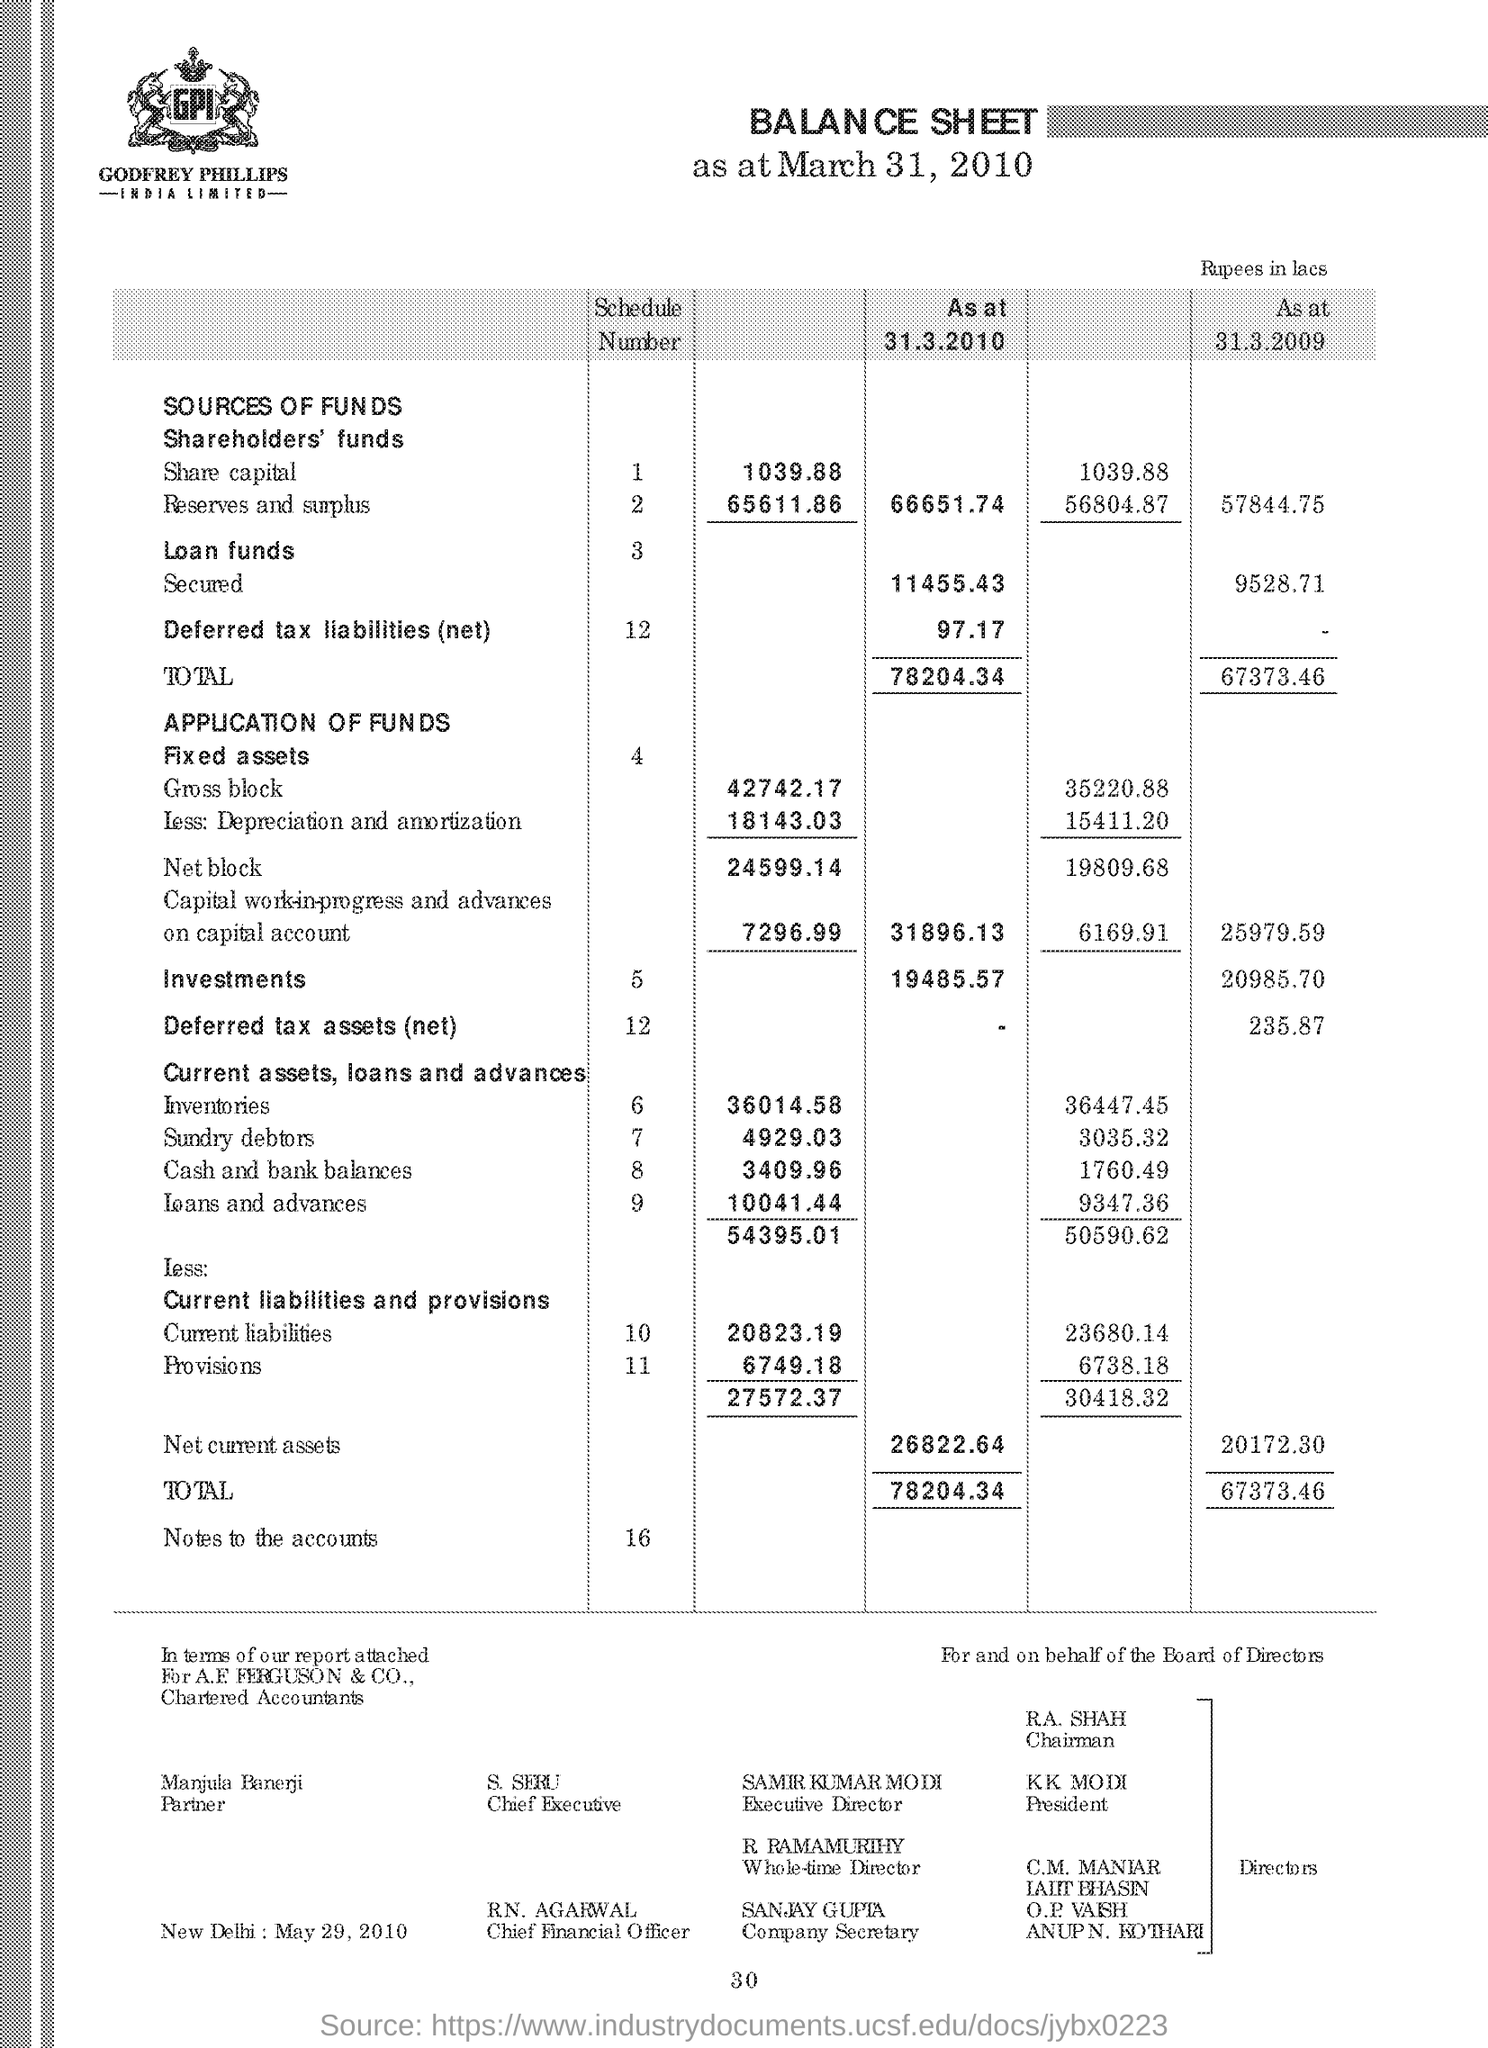What is the Net current assets as at 31.3.2010?
Provide a short and direct response. 26822.64. What is the Net current assets as at 31.3.2009?
Offer a terse response. 20172.30. What is the Total as at 31.3.2010?
Offer a terse response. 78204.34. What is the Total as at 31.3.2009?
Keep it short and to the point. 67373.46. Who is the Partner?
Offer a very short reply. Manjula Banerji. Who is the Executive Director?
Offer a very short reply. Samir Kumar Modi. Who is the Company Secretary?
Your response must be concise. SANJAY GUPTA. 